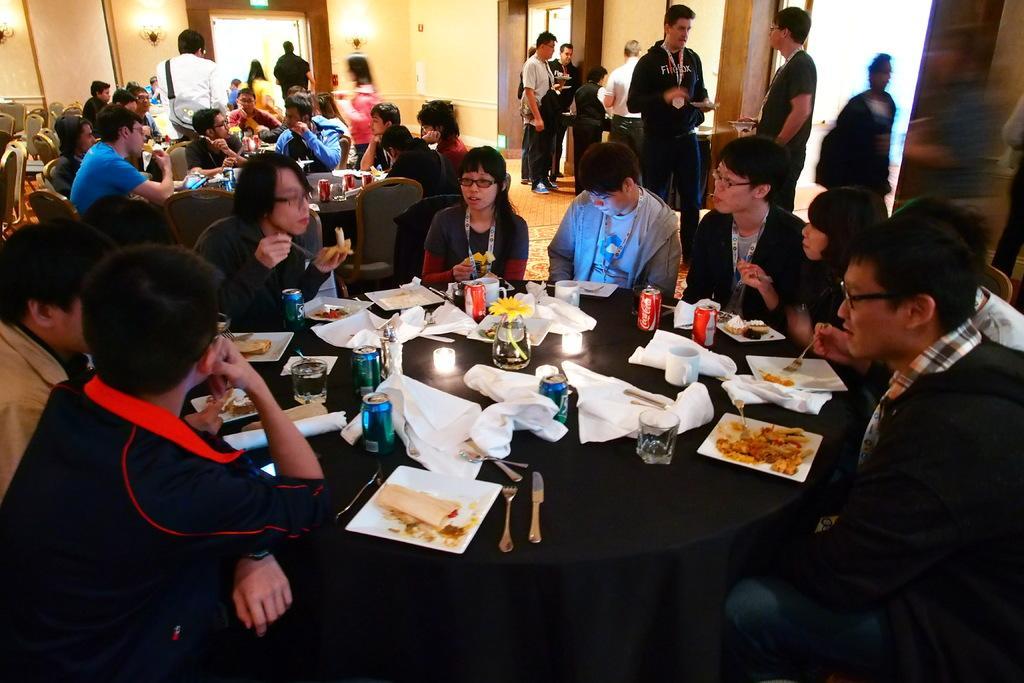In one or two sentences, can you explain what this image depicts? In this image i can see a group of people sitting on a chair and eating there few cans, candle, a flower pot, spoons on a table at the back ground i can see few other persons some are standing and some are sitting, a wall , a light. 